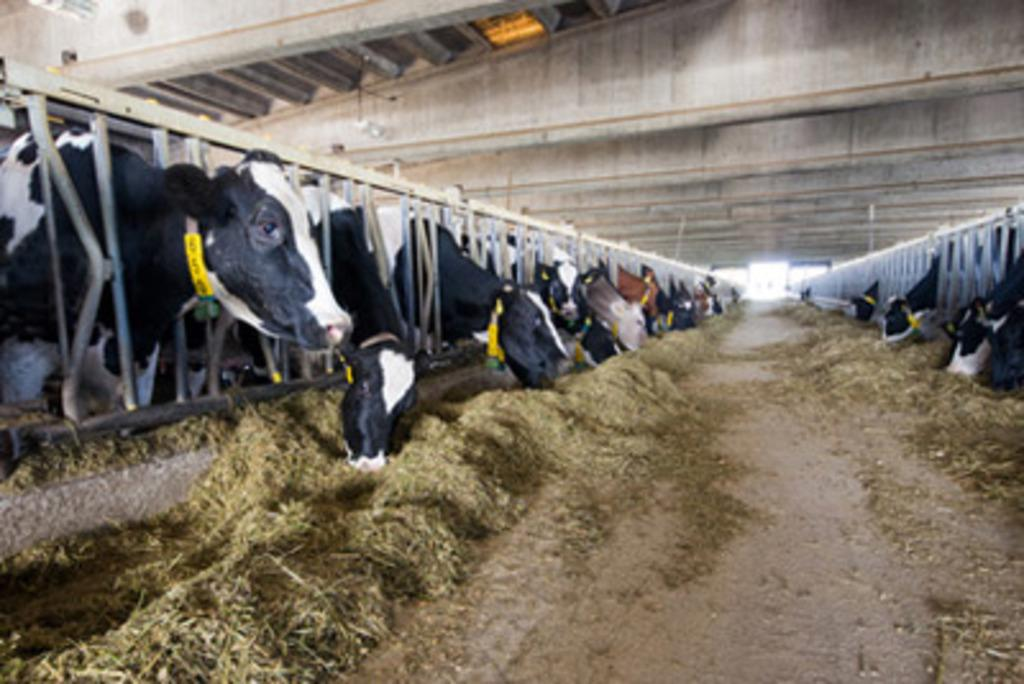What types of living organisms can be seen in the image? There are animals in the image. What type of vegetation is present in the image? There is grass in the image. What architectural feature can be seen in the image? There is a fence in the image. What type of window can be seen in the image? There is no window present in the image. What book is the animal reading in the image? There are no books or animals reading in the image. 